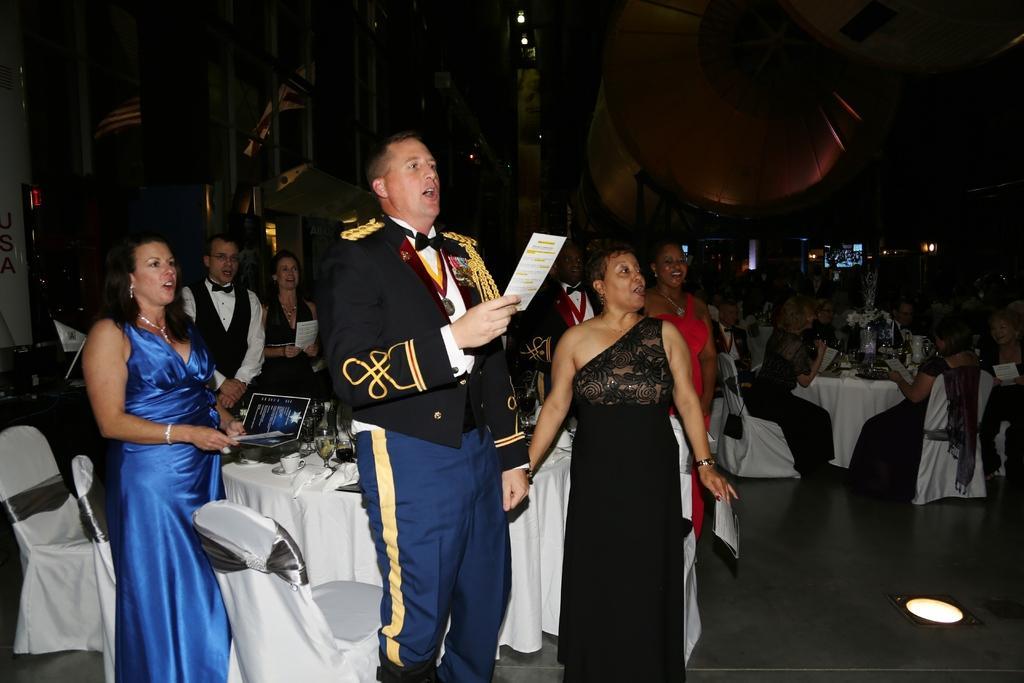How would you summarize this image in a sentence or two? In this image we can see a group of people standing on the floor. One person wearing black coat is holding a card in his hand. One woman is wearing a blue dress. In the background, we can see a group of people sitting on chairs in front of a table on which flowers are placed. 